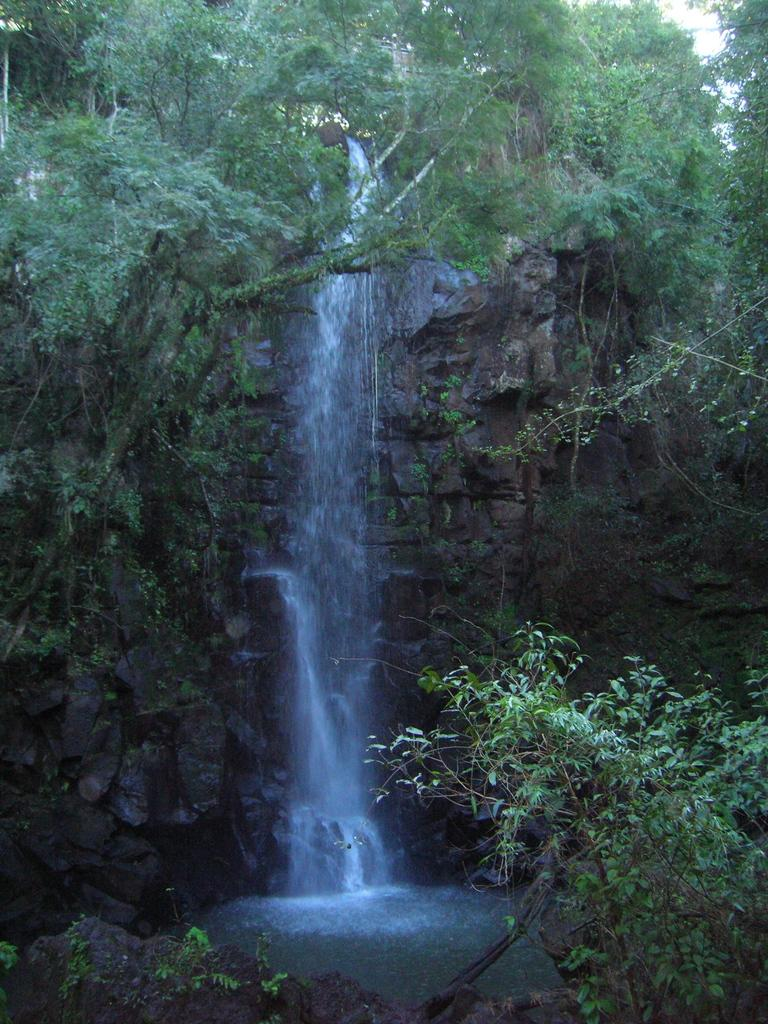What natural feature is the main subject of the image? There is a waterfall in the image. What type of vegetation can be seen in the image? There are trees in the image. What is visible at the bottom of the image? There is water visible at the bottom of the image. Can you tell me how many friends are sitting on the jelly in the image? There is no jelly or friends present in the image; it features a waterfall and trees. 